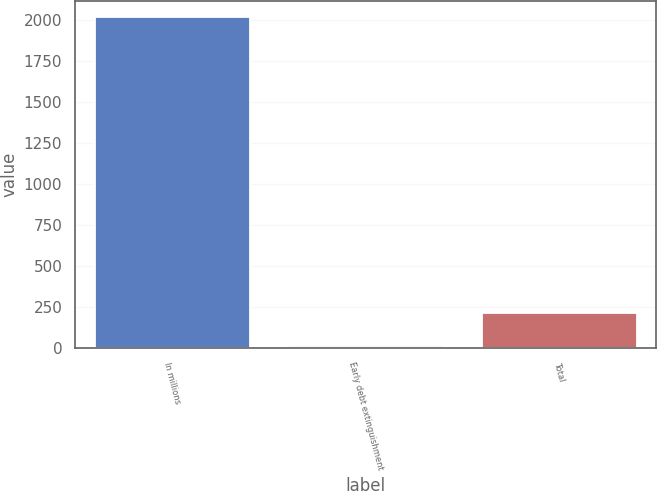Convert chart to OTSL. <chart><loc_0><loc_0><loc_500><loc_500><bar_chart><fcel>In millions<fcel>Early debt extinguishment<fcel>Total<nl><fcel>2018<fcel>10<fcel>210.8<nl></chart> 